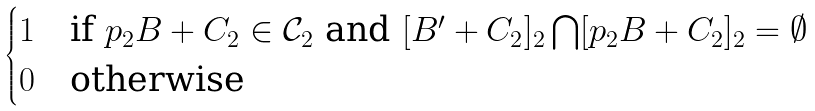Convert formula to latex. <formula><loc_0><loc_0><loc_500><loc_500>\begin{cases} 1 & \text {if } p _ { 2 } B + C _ { 2 } \in \mathcal { C } _ { 2 } \text { and } [ B ^ { \prime } + C _ { 2 } ] _ { 2 } \bigcap [ p _ { 2 } B + C _ { 2 } ] _ { 2 } = \emptyset \\ 0 & \text {otherwise} \end{cases}</formula> 